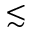<formula> <loc_0><loc_0><loc_500><loc_500>\lesssim</formula> 